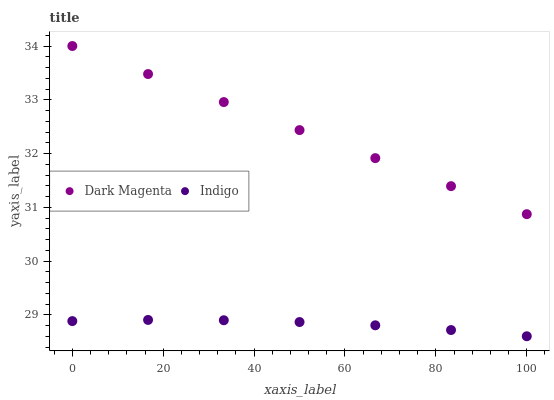Does Indigo have the minimum area under the curve?
Answer yes or no. Yes. Does Dark Magenta have the maximum area under the curve?
Answer yes or no. Yes. Does Dark Magenta have the minimum area under the curve?
Answer yes or no. No. Is Dark Magenta the smoothest?
Answer yes or no. Yes. Is Indigo the roughest?
Answer yes or no. Yes. Is Dark Magenta the roughest?
Answer yes or no. No. Does Indigo have the lowest value?
Answer yes or no. Yes. Does Dark Magenta have the lowest value?
Answer yes or no. No. Does Dark Magenta have the highest value?
Answer yes or no. Yes. Is Indigo less than Dark Magenta?
Answer yes or no. Yes. Is Dark Magenta greater than Indigo?
Answer yes or no. Yes. Does Indigo intersect Dark Magenta?
Answer yes or no. No. 